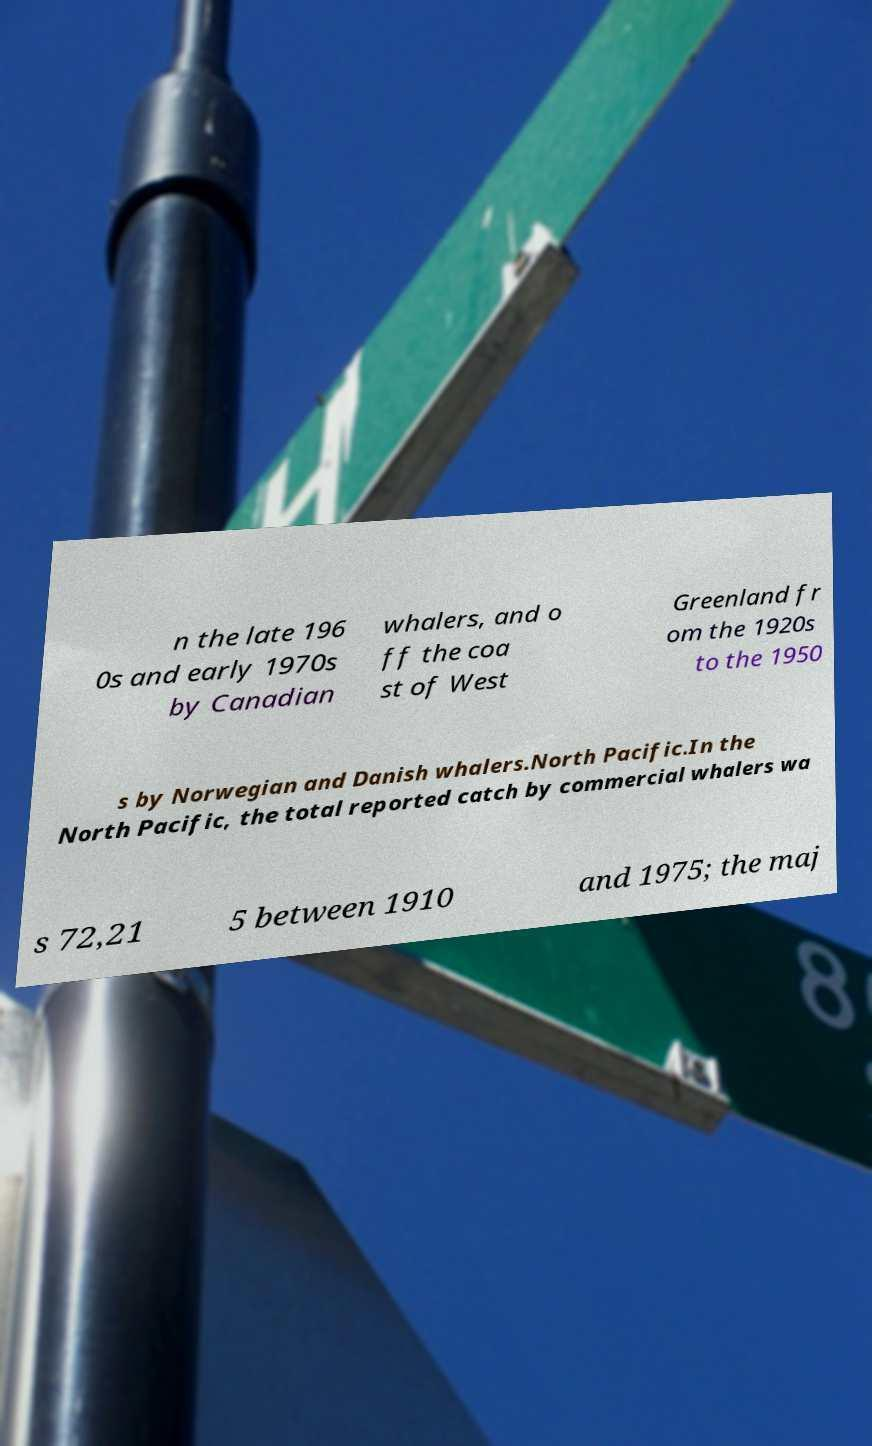Can you accurately transcribe the text from the provided image for me? n the late 196 0s and early 1970s by Canadian whalers, and o ff the coa st of West Greenland fr om the 1920s to the 1950 s by Norwegian and Danish whalers.North Pacific.In the North Pacific, the total reported catch by commercial whalers wa s 72,21 5 between 1910 and 1975; the maj 